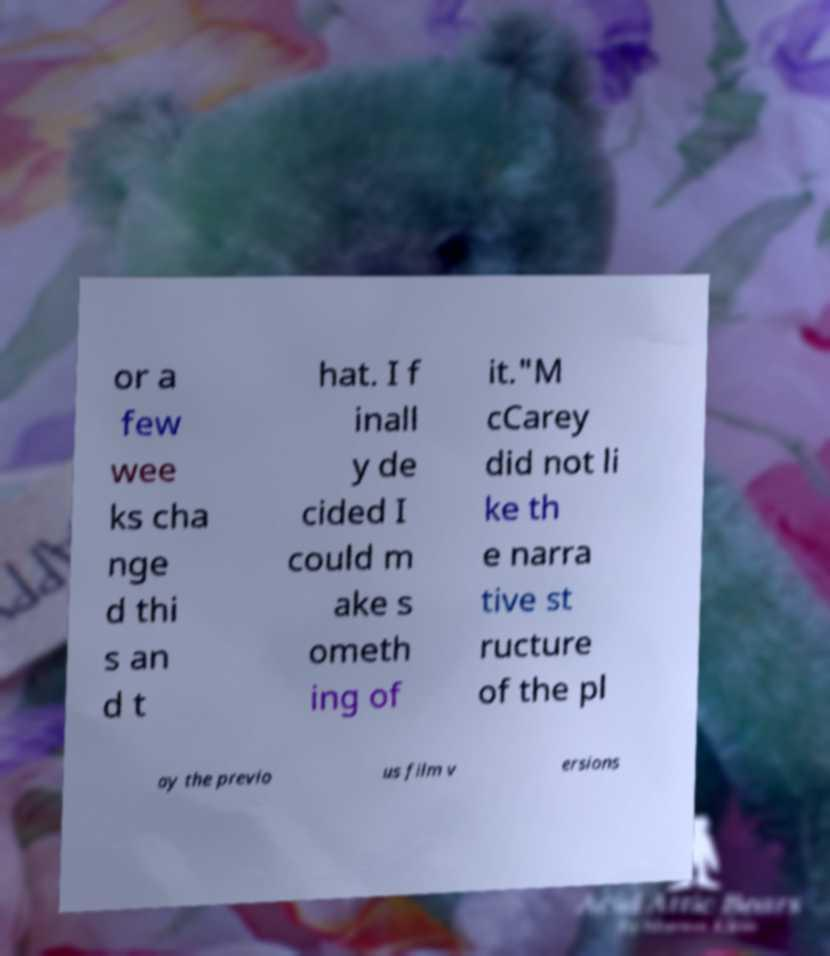Could you extract and type out the text from this image? or a few wee ks cha nge d thi s an d t hat. I f inall y de cided I could m ake s ometh ing of it."M cCarey did not li ke th e narra tive st ructure of the pl ay the previo us film v ersions 